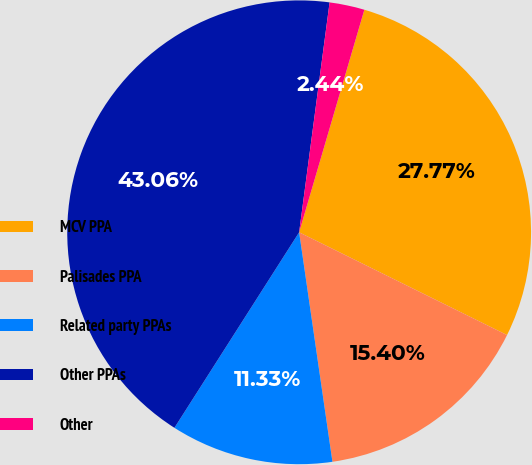Convert chart to OTSL. <chart><loc_0><loc_0><loc_500><loc_500><pie_chart><fcel>MCV PPA<fcel>Palisades PPA<fcel>Related party PPAs<fcel>Other PPAs<fcel>Other<nl><fcel>27.77%<fcel>15.4%<fcel>11.33%<fcel>43.06%<fcel>2.44%<nl></chart> 